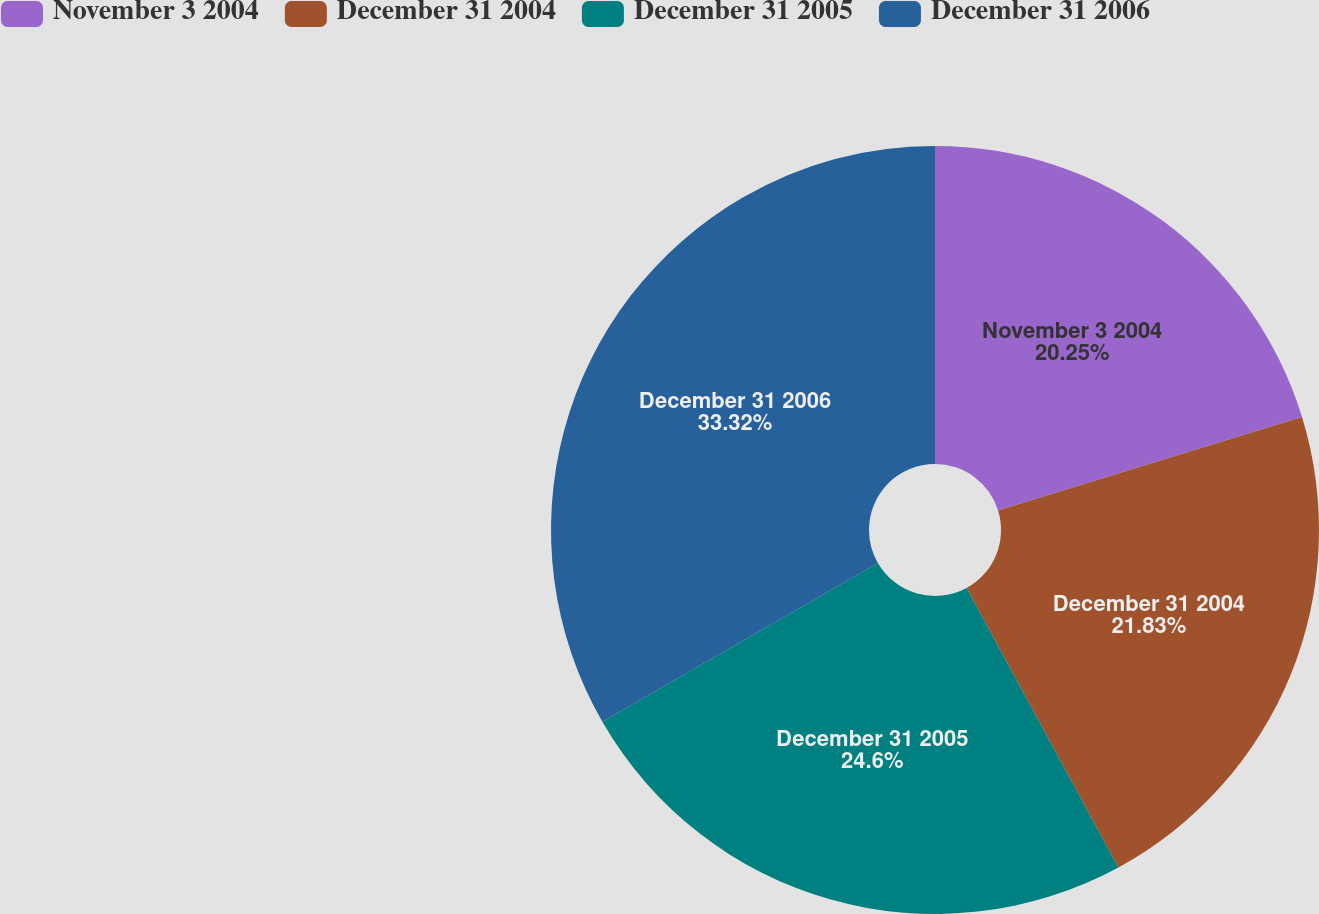<chart> <loc_0><loc_0><loc_500><loc_500><pie_chart><fcel>November 3 2004<fcel>December 31 2004<fcel>December 31 2005<fcel>December 31 2006<nl><fcel>20.25%<fcel>21.83%<fcel>24.6%<fcel>33.33%<nl></chart> 